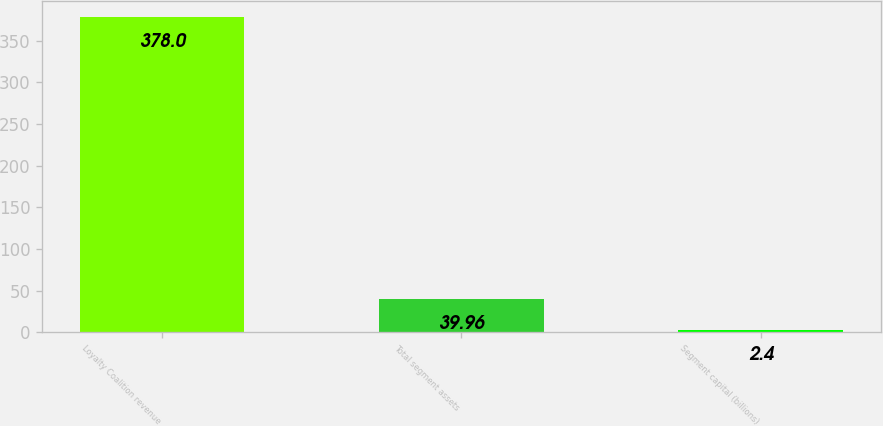<chart> <loc_0><loc_0><loc_500><loc_500><bar_chart><fcel>Loyalty Coalition revenue<fcel>Total segment assets<fcel>Segment capital (billions)<nl><fcel>378<fcel>39.96<fcel>2.4<nl></chart> 